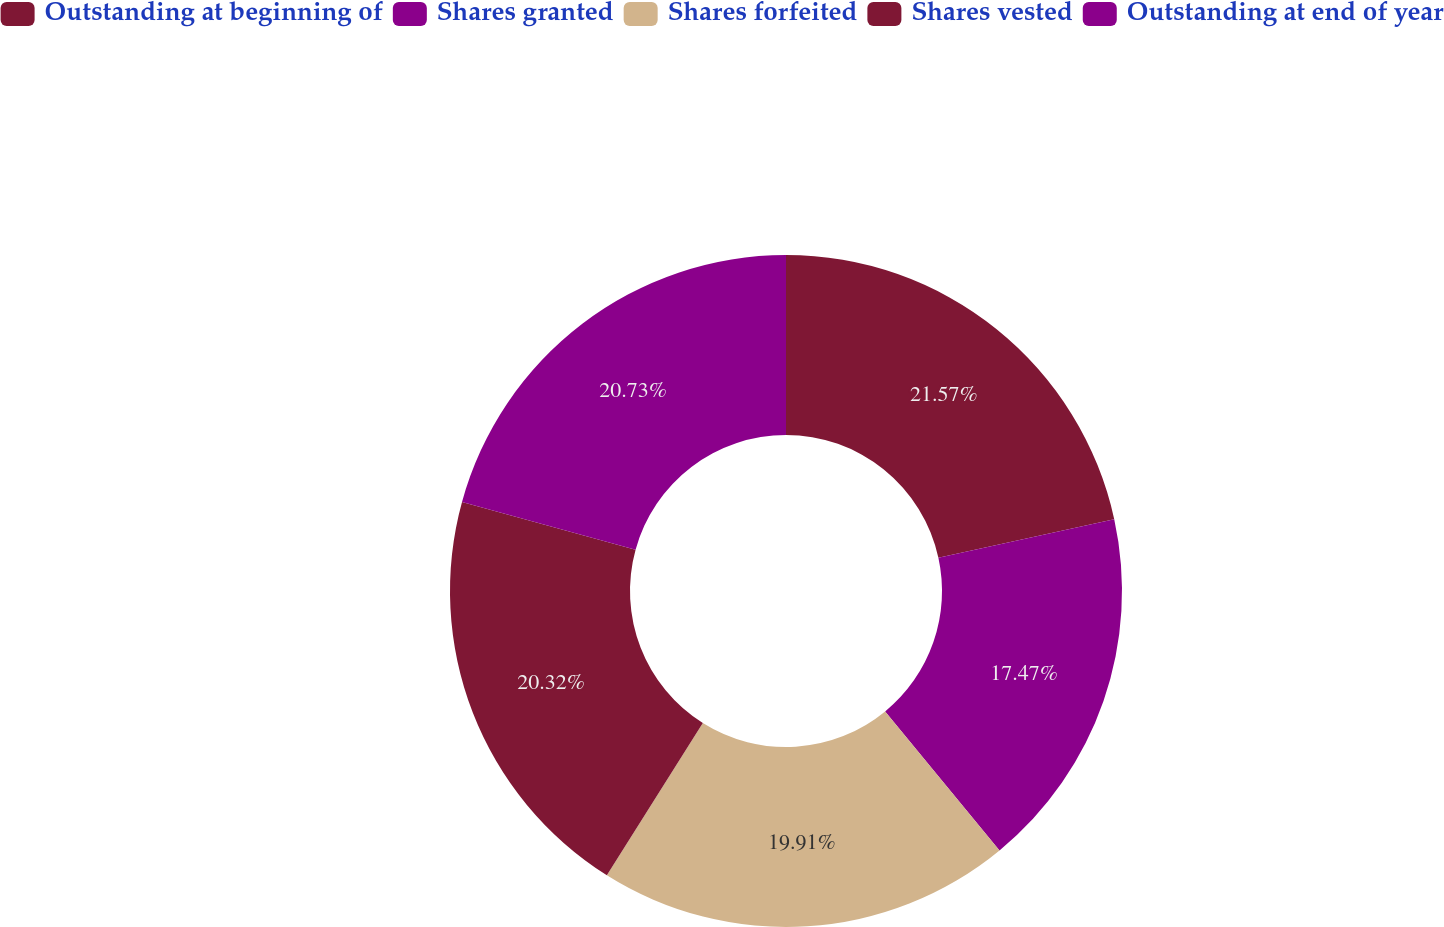<chart> <loc_0><loc_0><loc_500><loc_500><pie_chart><fcel>Outstanding at beginning of<fcel>Shares granted<fcel>Shares forfeited<fcel>Shares vested<fcel>Outstanding at end of year<nl><fcel>21.57%<fcel>17.47%<fcel>19.91%<fcel>20.32%<fcel>20.73%<nl></chart> 